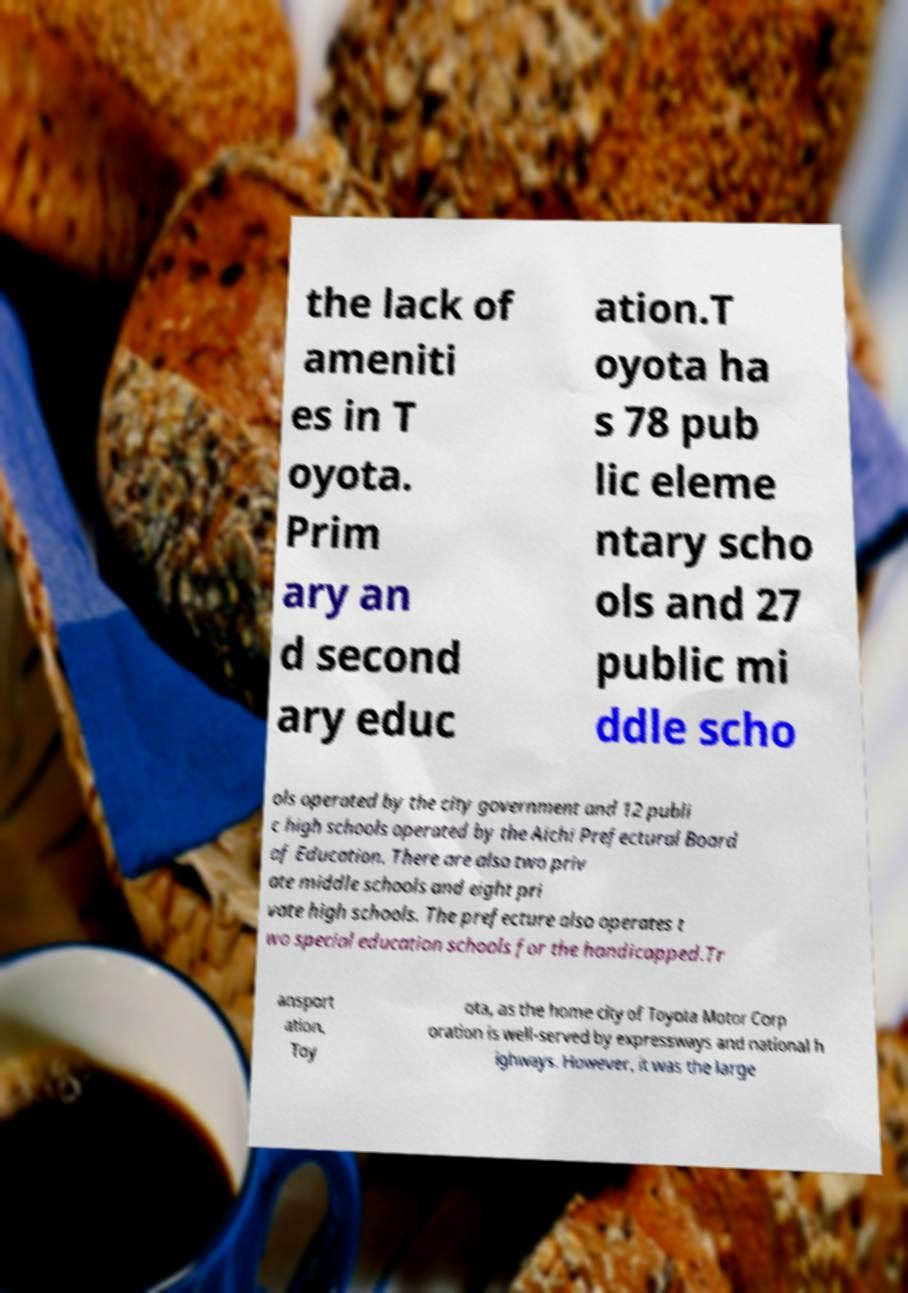What messages or text are displayed in this image? I need them in a readable, typed format. the lack of ameniti es in T oyota. Prim ary an d second ary educ ation.T oyota ha s 78 pub lic eleme ntary scho ols and 27 public mi ddle scho ols operated by the city government and 12 publi c high schools operated by the Aichi Prefectural Board of Education. There are also two priv ate middle schools and eight pri vate high schools. The prefecture also operates t wo special education schools for the handicapped.Tr ansport ation. Toy ota, as the home city of Toyota Motor Corp oration is well-served by expressways and national h ighways. However, it was the large 